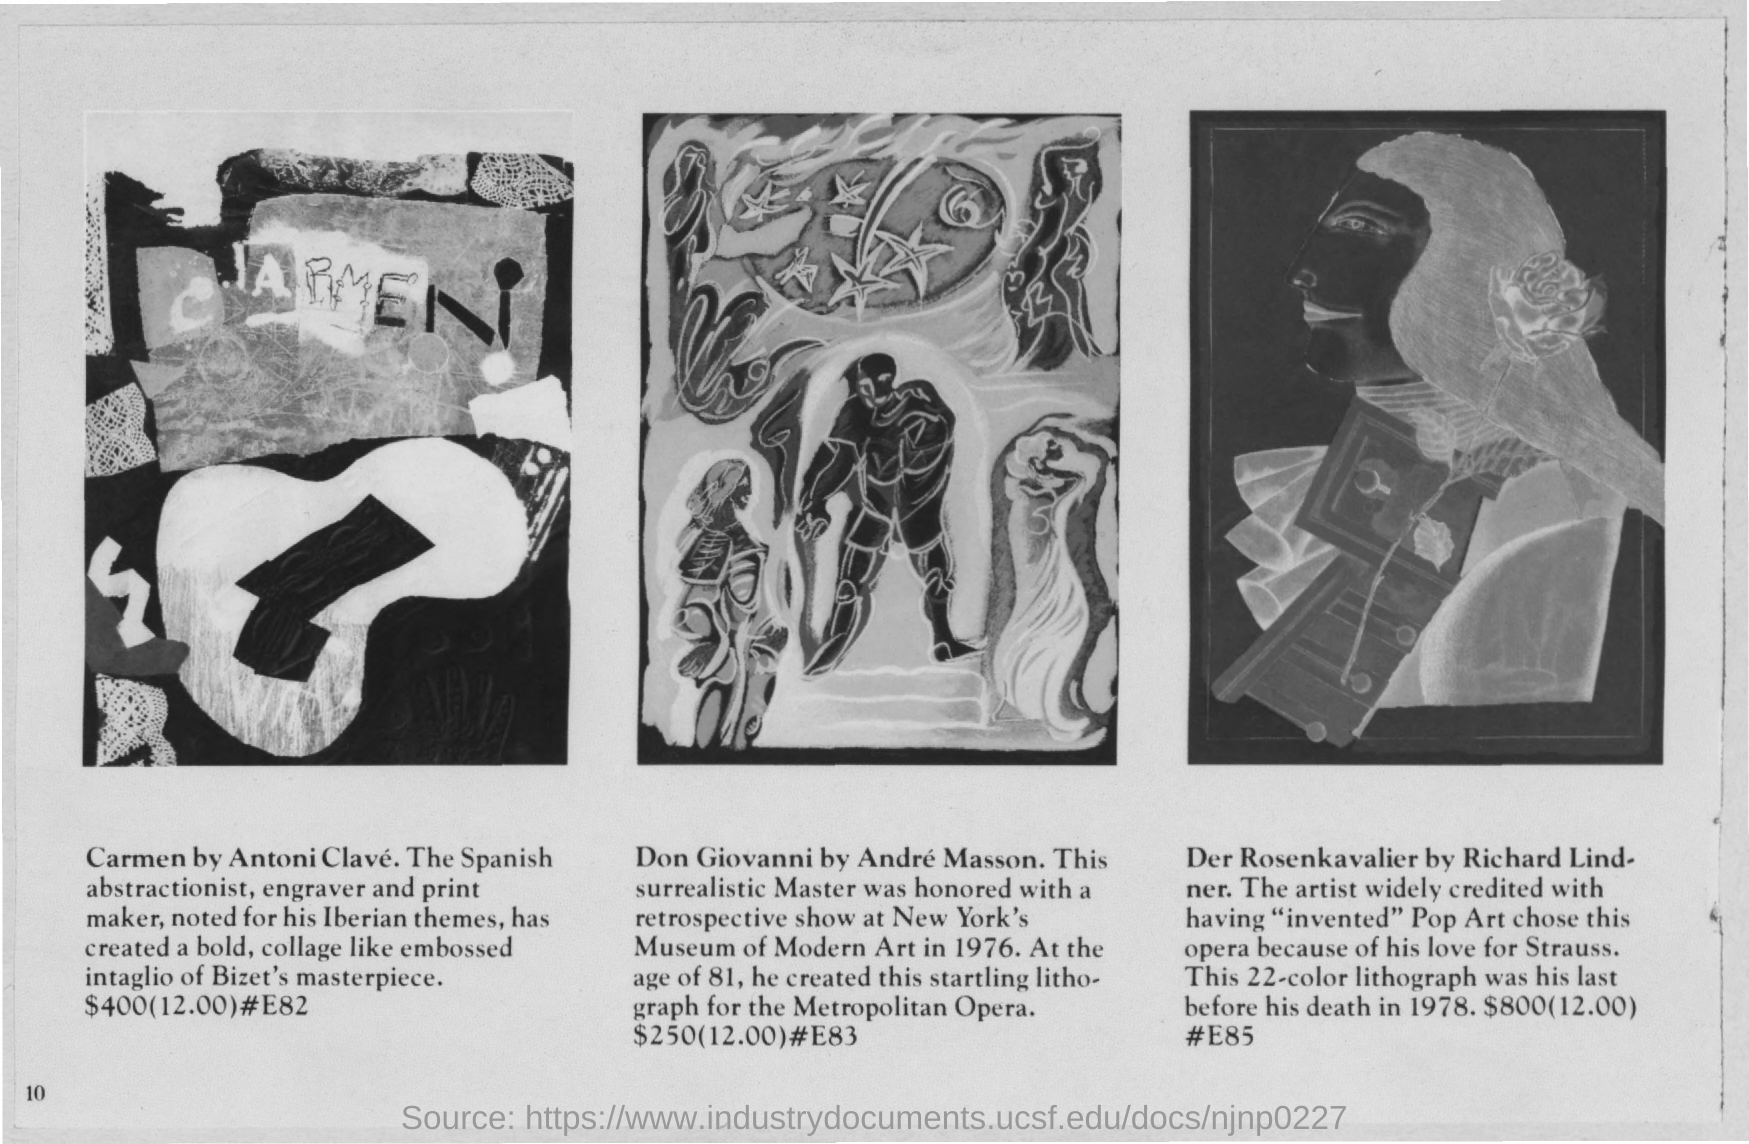Outline some significant characteristics in this image. The price of "Carmen" by Antoni Clave is $400. Andre Masson's "Don Giovanni" is priced at $250. 